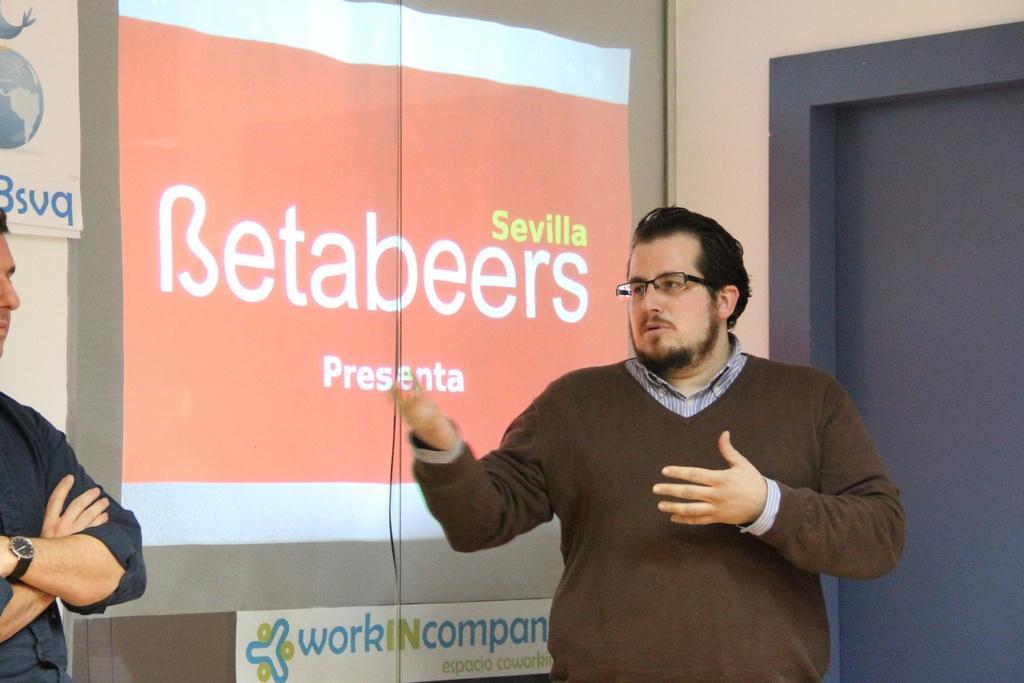In one or two sentences, can you explain what this image depicts? In this image we can see a man wearing the glasses and standing. On the left there is also another man. In the background we can see the display screen with the text. We can also see the pages with the text. On the right we can see the door and also the wall. 